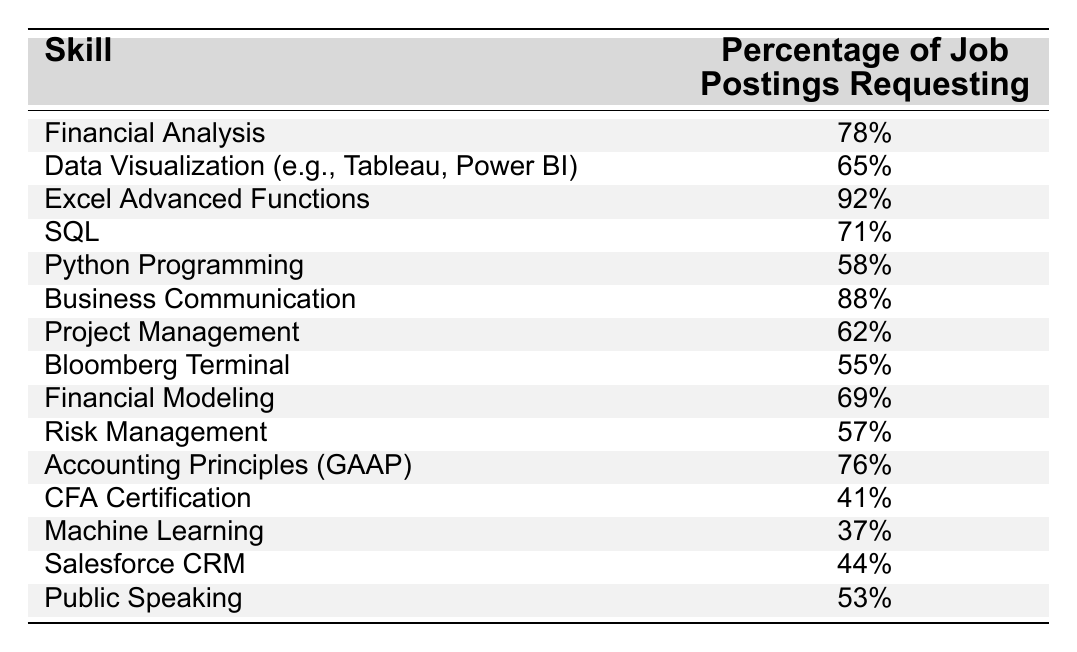What skill has the highest percentage request in job postings? The table shows that "Excel Advanced Functions" has the highest percentage at 92%.
Answer: Excel Advanced Functions Which skill has a lower percentage requested, SQL or Python Programming? SQL has a percentage of 71%, while Python Programming has 58%. Since 58% is less than 71%, Python Programming is the lower percentage.
Answer: Python Programming What percentage of job postings request Business Communication? According to the table, the percentage requesting "Business Communication" is 88%.
Answer: 88% Is the percentage of job postings requesting CFA Certification higher than that for Public Speaking? The percentage for CFA Certification is 41% and for Public Speaking it is 53%. Since 41% is less than 53%, the statement is false.
Answer: No What is the average percentage request of the top three skills? The top three skills are Excel Advanced Functions (92%), Business Communication (88%), and Financial Analysis (78%). Their sum is 92 + 88 + 78 = 258. Then, dividing by 3 gives an average of 258/3 = 86.
Answer: 86% How many skills have a percentage request above 70%? The skills with percentages above 70% are Excel Advanced Functions (92%), Business Communication (88%), Financial Analysis (78%), SQL (71%), and Accounting Principles (GAAP) (76%). There are a total of 5 skills that meet this criterion.
Answer: 5 Which skill has a percentage closest to 60%? Looking at the table, "Python Programming" at 58% and "Risk Management" at 57% are the closest to 60%. Since 58% is greater than 57%, Python Programming is the closest.
Answer: Python Programming What is the difference in percentage between the skill with the highest and lowest requests? The skill with the highest request is Excel Advanced Functions at 92%, while the lowest is Machine Learning at 37%. The difference is 92 - 37 = 55%.
Answer: 55% 